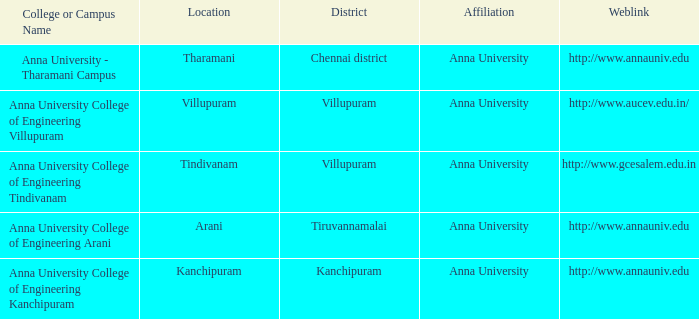Tharamani is situated in which district? Chennai district. 